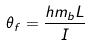<formula> <loc_0><loc_0><loc_500><loc_500>\theta _ { f } = \frac { h m _ { b } L } { I }</formula> 